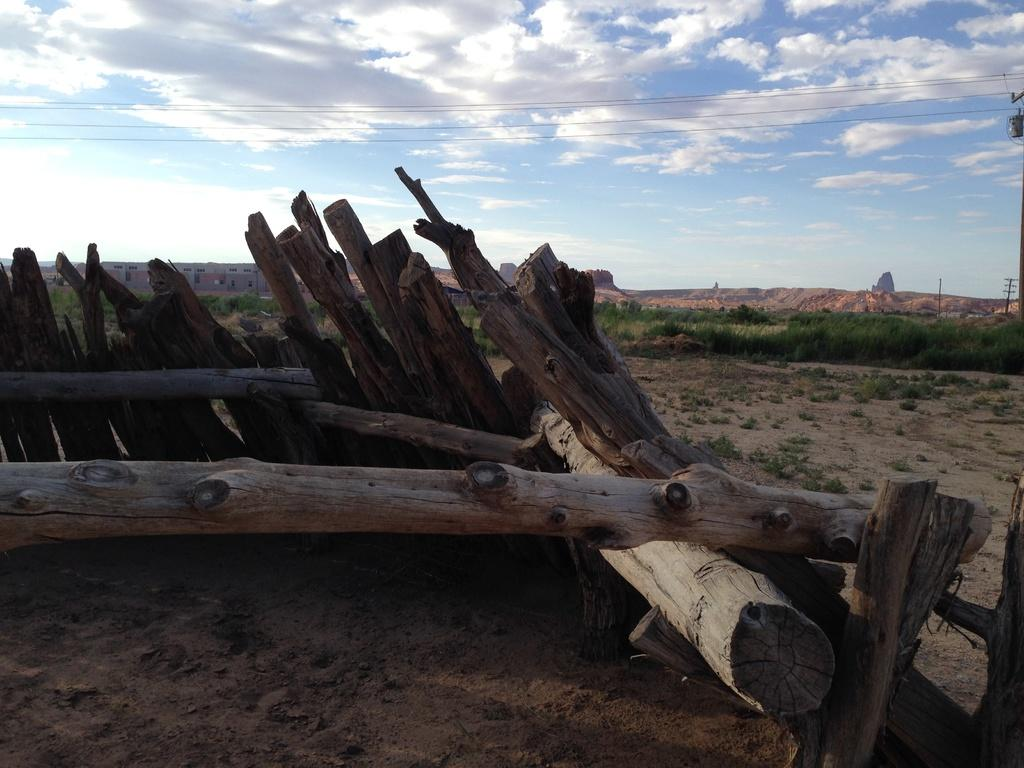What is the main subject in the center of the image? There are wooden logs in the center of the image. What can be seen in the background of the image? The sky, clouds, buildings, poles, wires, plants, grass, and soil are visible in the background of the image. Where is the spy hiding in the image? There is no spy present in the image. What type of crate can be seen in the image? There is no crate present in the image. 